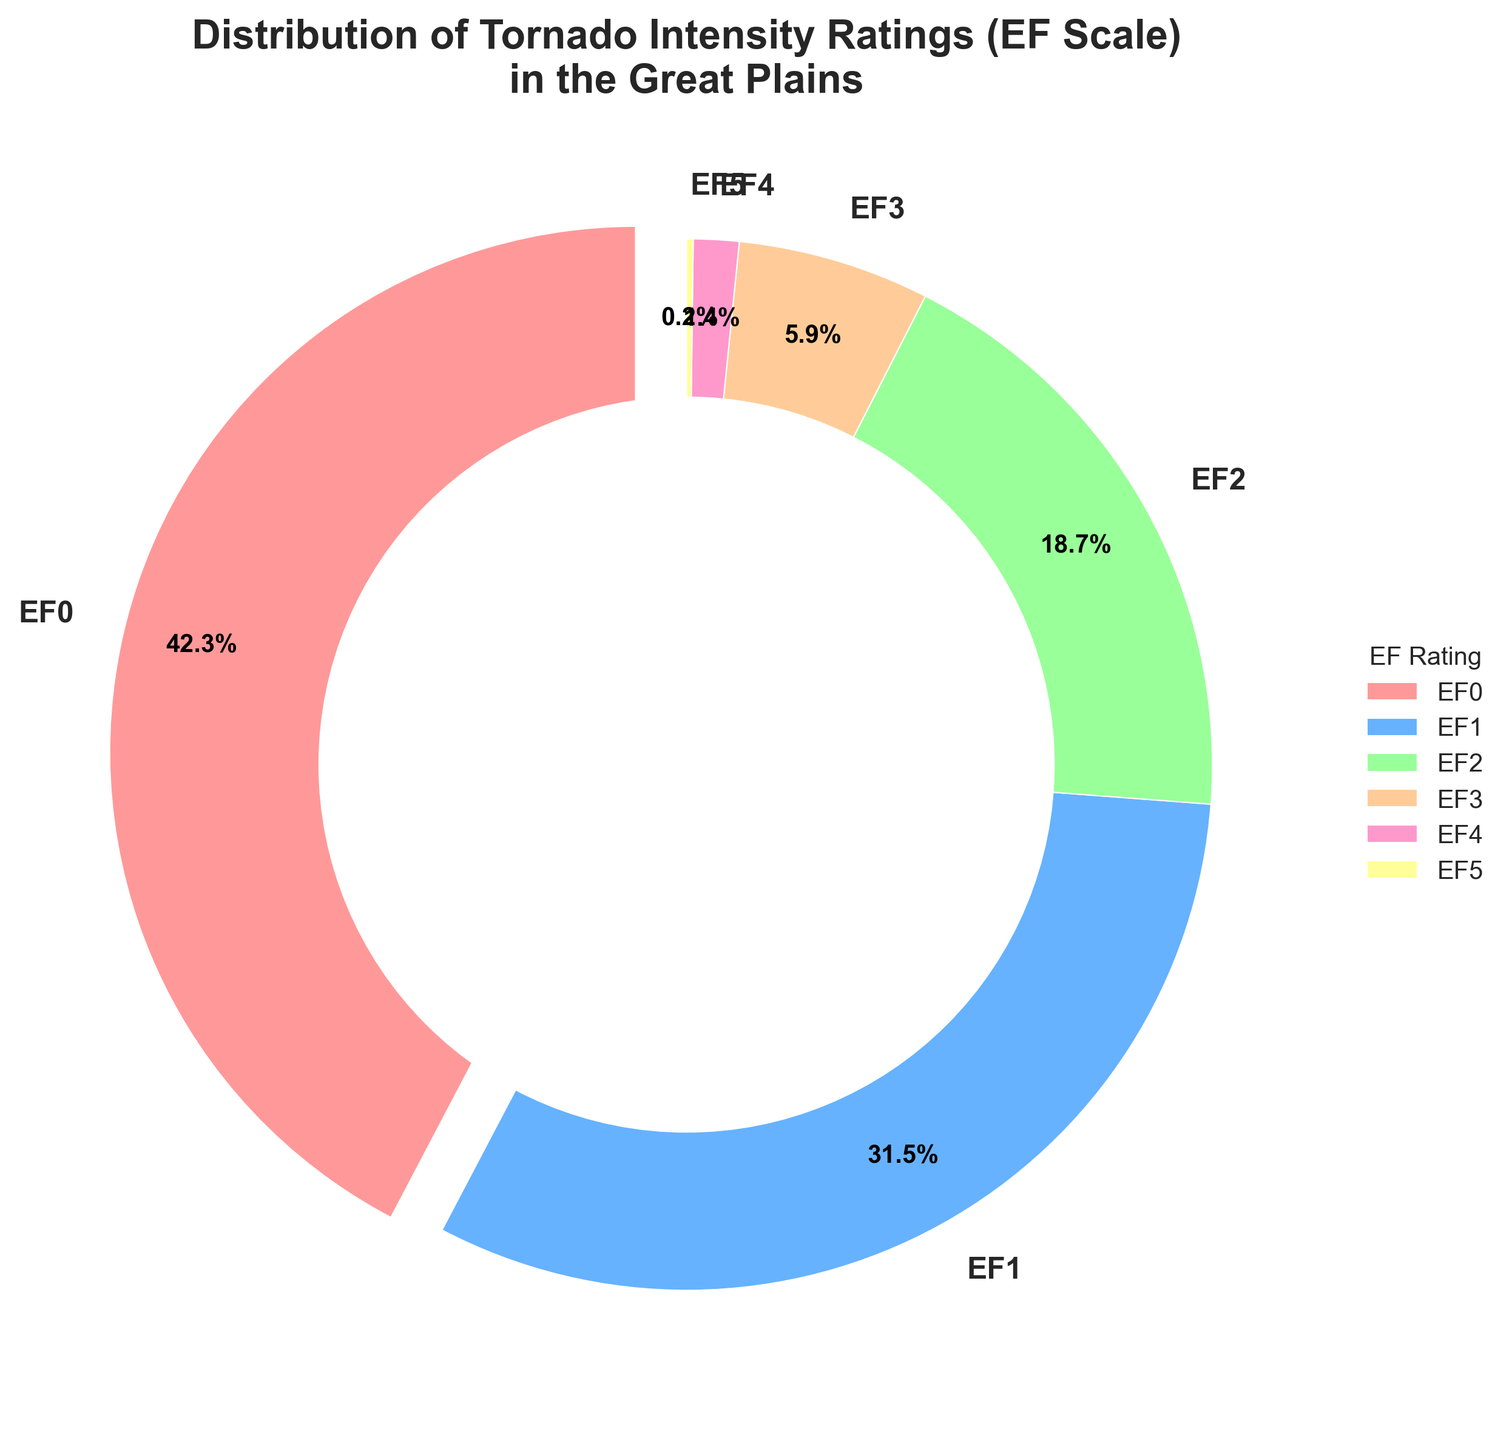Which EF rating category has the highest percentage? The EF rating category with the highest percentage can be identified by the largest wedge in the pie chart.
Answer: EF0 What is the percentage difference between EF0 and EF1 rated tornadoes? First, find the percentages of EF0 and EF1 from the pie chart (42.3% and 31.5% respectively). Then, subtract the smaller percentage from the larger one: 42.3% - 31.5% = 10.8%.
Answer: 10.8% Which EF rating categories combined make up over 50% of the tornadoes? Sum the percentages of each EF category from the pie chart, starting with the largest. EF0 (42.3%) + EF1 (31.5%) = 73.8%, which is over 50%. Hence, EF0 and EF1 combined make up over 50% of the tornadoes.
Answer: EF0 and EF1 What is the combined percentage of EF4 and EF5 tornadoes? Add the percentages of EF4 and EF5 from the pie chart: 1.4% + 0.2% = 1.6%.
Answer: 1.6% By how much does the percentage of EF0 tornadoes exceed that of EF3 tornadoes? Find the percentages of EF0 and EF3 from the pie chart and subtract the smaller one from the larger one: 42.3% - 5.9% = 36.4%.
Answer: 36.4% How many times greater is the percentage of EF0 tornadoes compared to EF2 tornadoes? Divide the percentage of EF0 by the percentage of EF2: 42.3% / 18.7% ≈ 2.26.
Answer: Approximately 2.26 times Which wedge is the smallest in the pie chart, and what is its percentage? Identify the smallest wedge by visual inspection and look at its label for the percentage. The smallest wedge corresponds to EF5, with a percentage of 0.2%.
Answer: EF5, 0.2% What is the percentage of tornadoes that are at least EF3? Sum the percentages of EF3, EF4, and EF5 from the pie chart: 5.9% + 1.4% + 0.2% = 7.5%.
Answer: 7.5% Compare the combined percentage of EF0 and EF1 tornadoes to the combined percentage of EF2, EF3, EF4, and EF5 tornadoes. Which group is larger, and by how much? First, calculate the combined percentages: EF0 + EF1 = 42.3% + 31.5% = 73.8%. Then, EF2 + EF3 + EF4 + EF5 = 18.7% + 5.9% + 1.4% + 0.2% = 26.2%. The difference is 73.8% - 26.2% = 47.6%.
Answer: EF0 and EF1, by 47.6% What proportion of the tornadoes have an intensity rating of EF2 or lower? Sum the percentages of EF0, EF1, and EF2: 42.3% + 31.5% + 18.7% = 92.5%.
Answer: 92.5% 